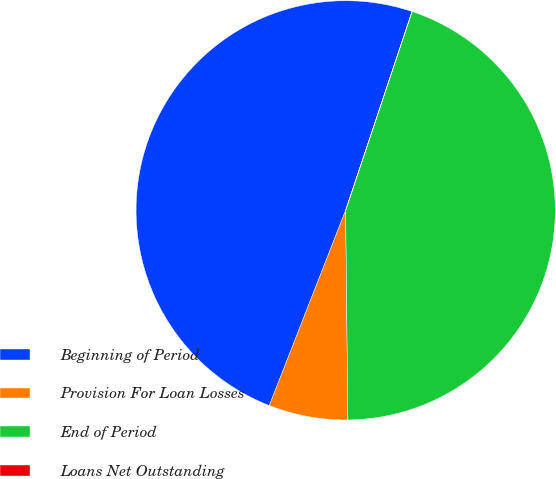Convert chart to OTSL. <chart><loc_0><loc_0><loc_500><loc_500><pie_chart><fcel>Beginning of Period<fcel>Provision For Loan Losses<fcel>End of Period<fcel>Loans Net Outstanding<nl><fcel>49.19%<fcel>6.1%<fcel>44.69%<fcel>0.01%<nl></chart> 